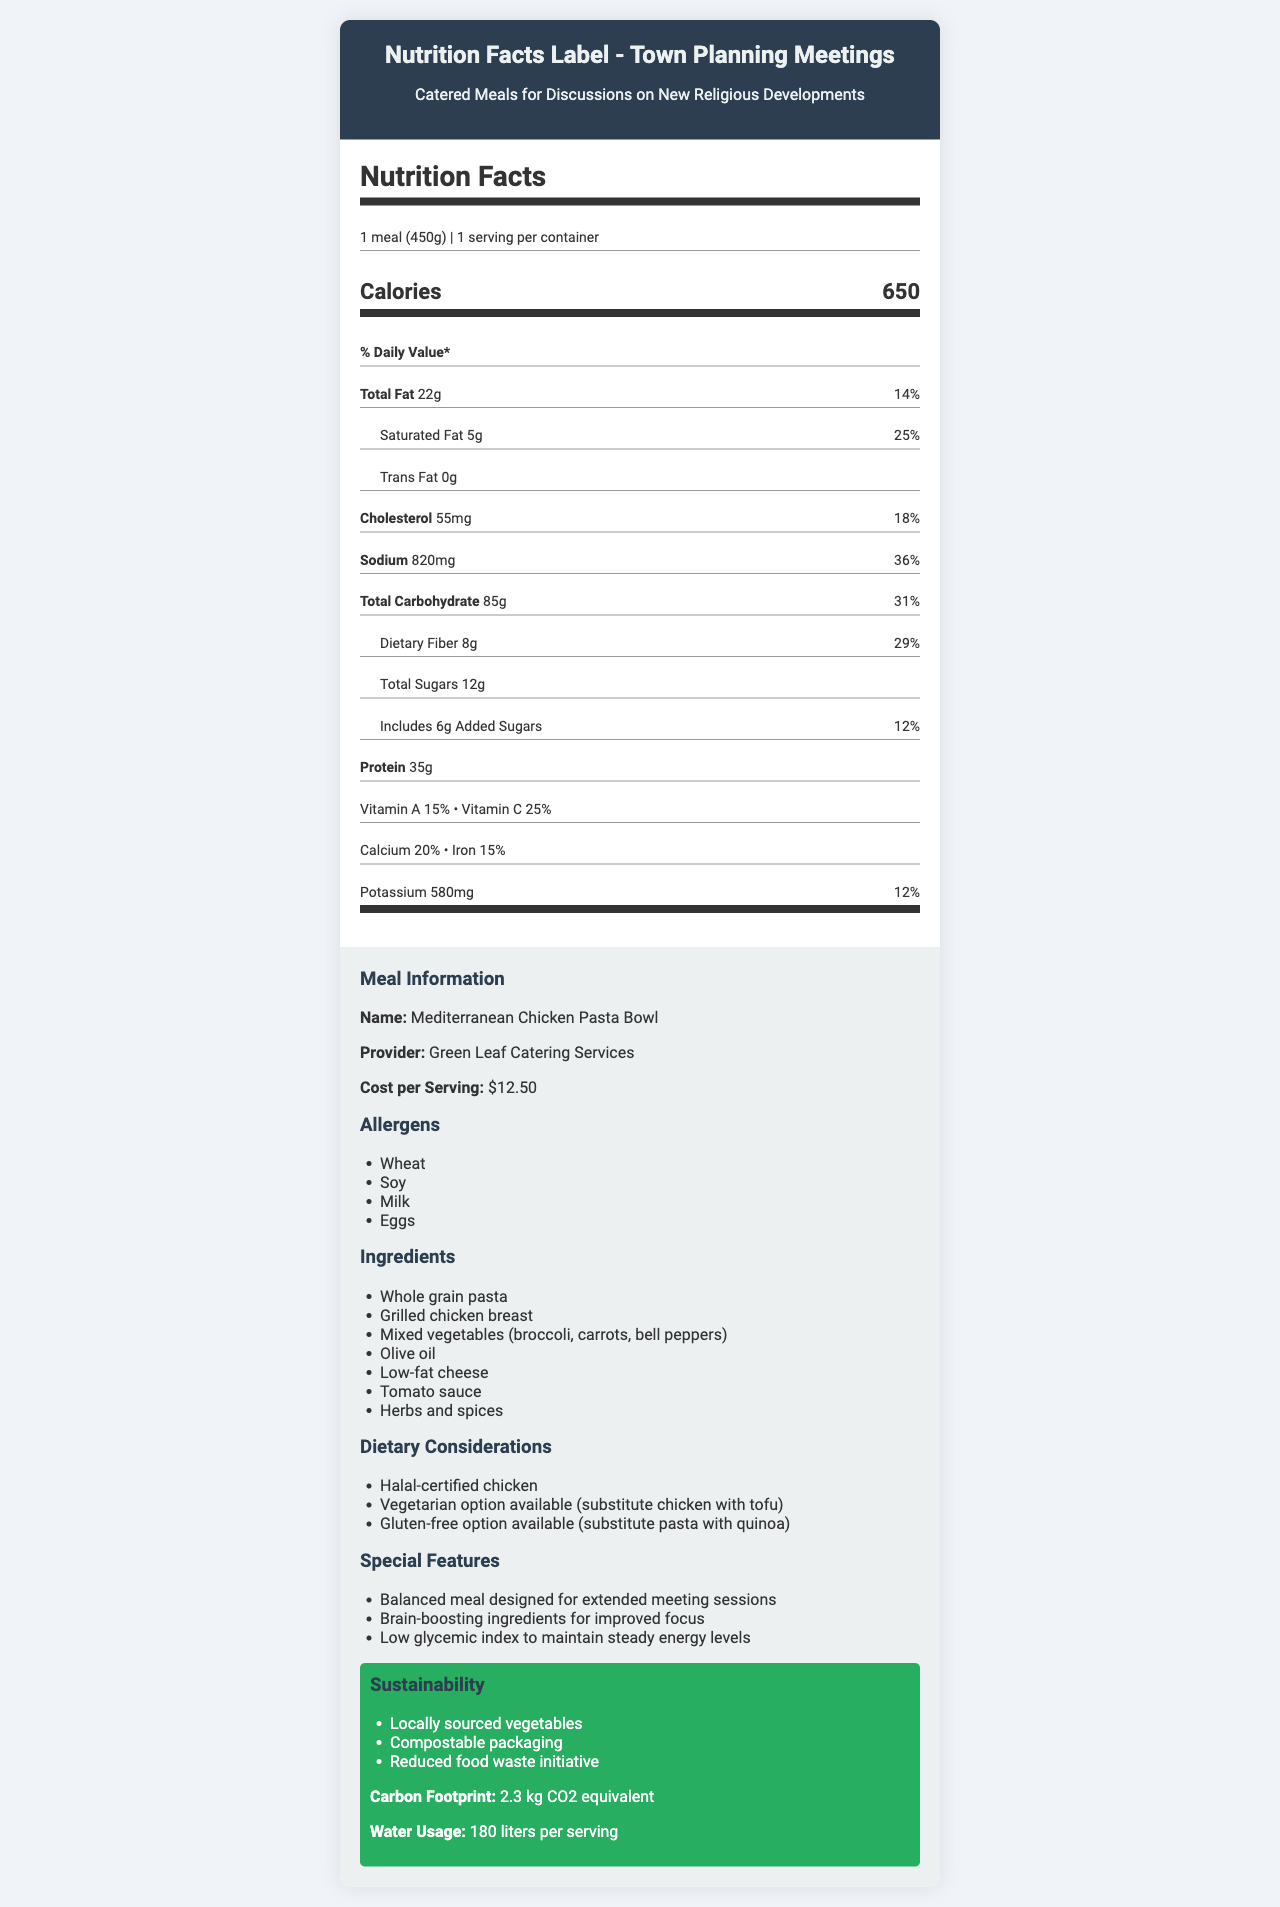what is the serving size? The document specifies the serving size as 1 meal, which corresponds to 450 grams.
Answer: 1 meal (450g) how many calories are in one serving? The document states that one serving contains 650 calories.
Answer: 650 What is the total fat content per serving in grams? The document lists the total fat content as 22 grams per serving.
Answer: 22g What allergens are included in the meal? The document contains a section that lists the allergens present in the meal as Wheat, Soy, Milk, and Eggs.
Answer: Wheat, Soy, Milk, Eggs Name one dietary consideration mentioned for the catered meal. The document mentions that the meal includes Halal-certified chicken as one of the dietary considerations.
Answer: Halal-certified chicken What is the cost per serving? A. $10.00 B. $12.50 C. $15.00 D. $20.00 The document specifies that the cost per serving is $12.50.
Answer: B The meal is suitable for which dietary preference if substituting chicken with tofu? I. Vegetarian II. Vegan III. Pescatarian IV. Paleo The document states that substituting chicken with tofu makes the meal suitable for vegetarians.
Answer: I Is the meal nutritionist approved? The document mentions that the meal is approved by a nutritionist.
Answer: Yes Does the meal contain any trans fat? The document specifies that the meal contains 0 grams of trans fat.
Answer: No Summarize the main features of this document. The document is primarily designed to inform town planning officers about the nutritional content and other relevant details of the catered meal to be served at town planning meetings discussing new religious developments.
Answer: This document provides nutritional information for a catered meal called "Mediterranean Chicken Pasta Bowl" offered by Green Leaf Catering Services. It includes details on serving size, calories, fat content, sodium, carbohydrates, protein, vitamins, and minerals. The document also lists allergens, ingredients, dietary considerations, special features, and sustainability notes. Additionally, it highlights the cost per serving, carbon footprint, and water usage. What is the total percentage of daily value for sodium in the meal? The document mentions that the meal contains 820mg of sodium, which amounts to 36% of the daily value.
Answer: 36% What is the water usage per serving for the meal? The document indicates that the water usage per serving is 180 liters.
Answer: 180 liters Explain the sustainability efforts noted for the meal. A. Locally sourced vegetables B. Compostable packaging C. Solar-powered cooking D. Reduced food waste initiative The document states that the sustainability efforts for the meal include locally sourced vegetables, compostable packaging, and a reduced food waste initiative. Solar-powered cooking is not mentioned.
Answer: A, B, D Were the broccoli used locally sourced? The document mentions that vegetables are locally sourced but does not provide specific information about broccoli.
Answer: Not enough information 